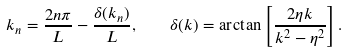<formula> <loc_0><loc_0><loc_500><loc_500>k _ { n } = \frac { 2 n \pi } { L } - \frac { \delta ( k _ { n } ) } { L } , \quad \delta ( k ) = \arctan \left [ \frac { 2 \eta k } { k ^ { 2 } - \eta ^ { 2 } } \right ] .</formula> 